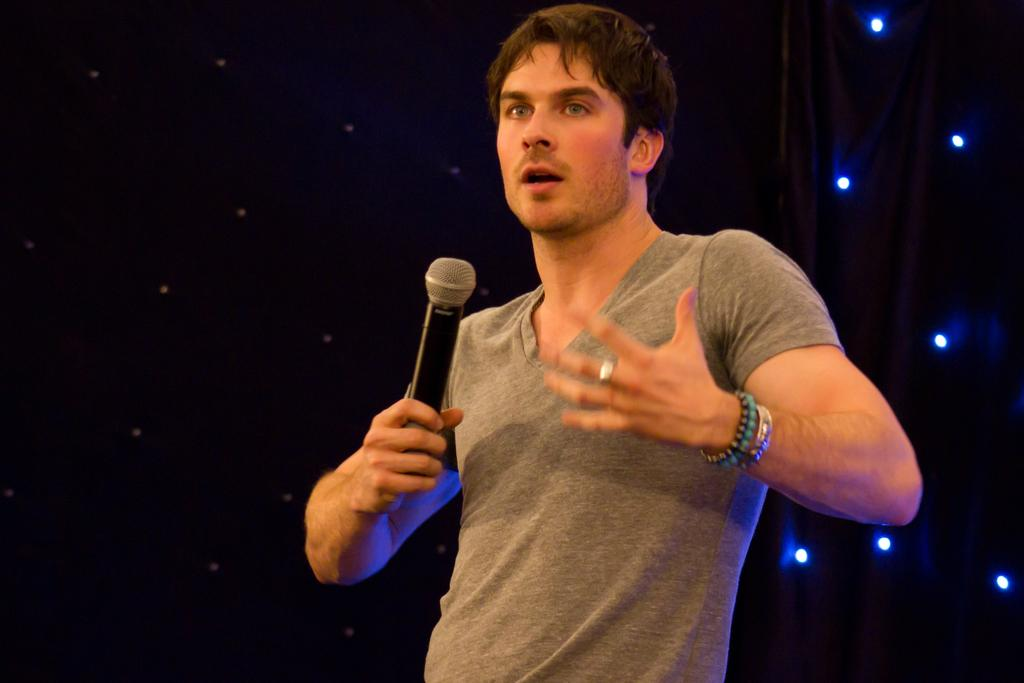What is the main subject of the image? There is a man standing in the middle of the image. What is the man holding in the image? The man is holding a microphone. What can be seen behind the man in the image? There are lights visible behind the man. What type of offer is the man making to the baby in the image? There is no baby present in the image, so no offer can be made to a baby. 